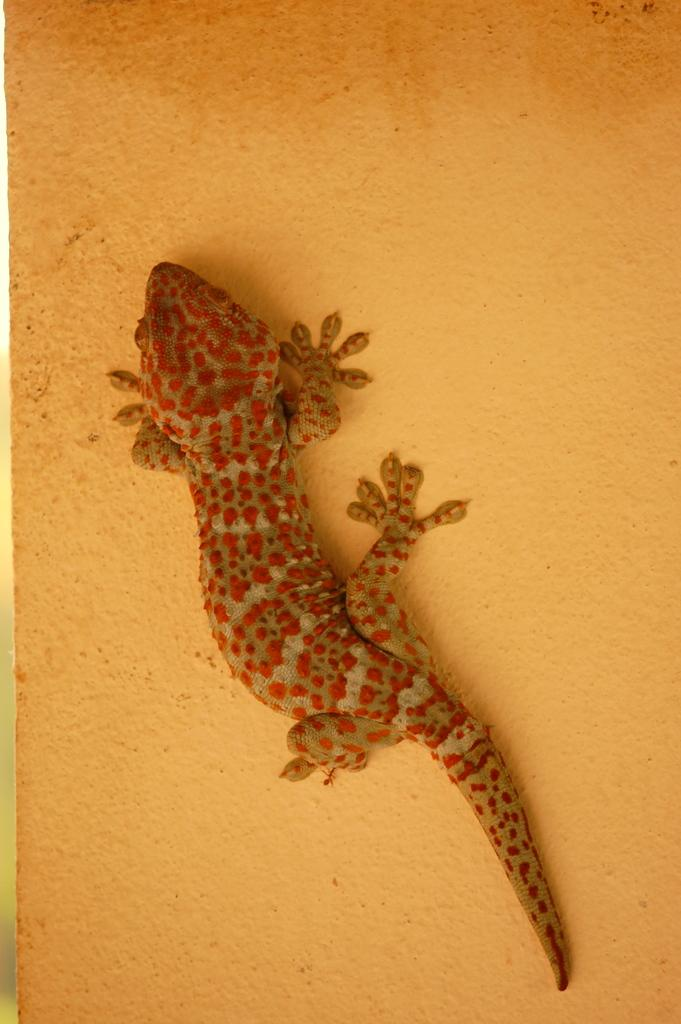What type of animal is in the image? There is a lizard in the image. Where is the lizard located? The lizard is on the wall. Is there a river flowing through the image? No, there is no river present in the image; it only features a lizard on the wall. 